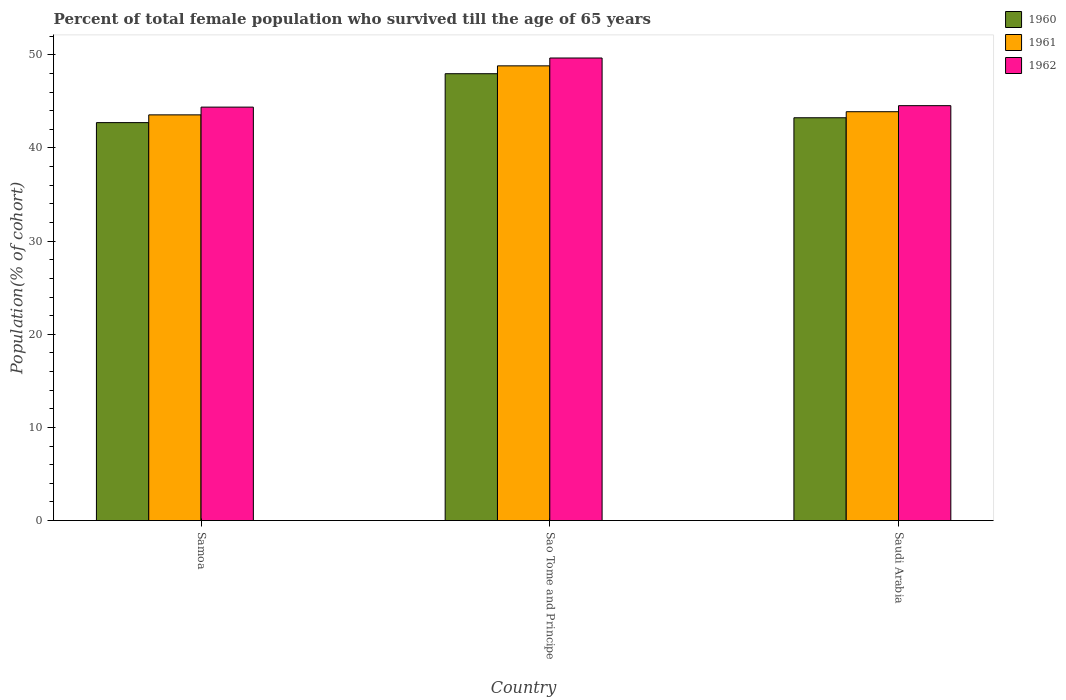How many groups of bars are there?
Your answer should be very brief. 3. How many bars are there on the 2nd tick from the left?
Give a very brief answer. 3. What is the label of the 3rd group of bars from the left?
Offer a very short reply. Saudi Arabia. What is the percentage of total female population who survived till the age of 65 years in 1960 in Samoa?
Your answer should be very brief. 42.72. Across all countries, what is the maximum percentage of total female population who survived till the age of 65 years in 1960?
Ensure brevity in your answer.  47.97. Across all countries, what is the minimum percentage of total female population who survived till the age of 65 years in 1960?
Keep it short and to the point. 42.72. In which country was the percentage of total female population who survived till the age of 65 years in 1960 maximum?
Ensure brevity in your answer.  Sao Tome and Principe. In which country was the percentage of total female population who survived till the age of 65 years in 1962 minimum?
Provide a short and direct response. Samoa. What is the total percentage of total female population who survived till the age of 65 years in 1962 in the graph?
Ensure brevity in your answer.  138.58. What is the difference between the percentage of total female population who survived till the age of 65 years in 1962 in Sao Tome and Principe and that in Saudi Arabia?
Make the answer very short. 5.12. What is the difference between the percentage of total female population who survived till the age of 65 years in 1960 in Samoa and the percentage of total female population who survived till the age of 65 years in 1962 in Saudi Arabia?
Offer a very short reply. -1.82. What is the average percentage of total female population who survived till the age of 65 years in 1961 per country?
Provide a short and direct response. 45.42. What is the difference between the percentage of total female population who survived till the age of 65 years of/in 1962 and percentage of total female population who survived till the age of 65 years of/in 1960 in Saudi Arabia?
Your answer should be compact. 1.3. In how many countries, is the percentage of total female population who survived till the age of 65 years in 1961 greater than 32 %?
Keep it short and to the point. 3. What is the ratio of the percentage of total female population who survived till the age of 65 years in 1961 in Samoa to that in Saudi Arabia?
Provide a short and direct response. 0.99. Is the difference between the percentage of total female population who survived till the age of 65 years in 1962 in Samoa and Sao Tome and Principe greater than the difference between the percentage of total female population who survived till the age of 65 years in 1960 in Samoa and Sao Tome and Principe?
Your response must be concise. No. What is the difference between the highest and the second highest percentage of total female population who survived till the age of 65 years in 1961?
Your answer should be compact. 5.26. What is the difference between the highest and the lowest percentage of total female population who survived till the age of 65 years in 1960?
Your answer should be compact. 5.25. What does the 1st bar from the left in Sao Tome and Principe represents?
Your answer should be compact. 1960. What does the 3rd bar from the right in Sao Tome and Principe represents?
Provide a succinct answer. 1960. How many countries are there in the graph?
Your response must be concise. 3. What is the difference between two consecutive major ticks on the Y-axis?
Your response must be concise. 10. Does the graph contain grids?
Offer a terse response. No. Where does the legend appear in the graph?
Your answer should be compact. Top right. How many legend labels are there?
Your response must be concise. 3. What is the title of the graph?
Your answer should be very brief. Percent of total female population who survived till the age of 65 years. Does "1991" appear as one of the legend labels in the graph?
Make the answer very short. No. What is the label or title of the X-axis?
Your answer should be very brief. Country. What is the label or title of the Y-axis?
Provide a short and direct response. Population(% of cohort). What is the Population(% of cohort) of 1960 in Samoa?
Your answer should be compact. 42.72. What is the Population(% of cohort) of 1961 in Samoa?
Provide a short and direct response. 43.55. What is the Population(% of cohort) of 1962 in Samoa?
Your answer should be compact. 44.39. What is the Population(% of cohort) in 1960 in Sao Tome and Principe?
Your answer should be very brief. 47.97. What is the Population(% of cohort) of 1961 in Sao Tome and Principe?
Your answer should be very brief. 48.81. What is the Population(% of cohort) of 1962 in Sao Tome and Principe?
Your answer should be very brief. 49.66. What is the Population(% of cohort) in 1960 in Saudi Arabia?
Keep it short and to the point. 43.24. What is the Population(% of cohort) in 1961 in Saudi Arabia?
Your response must be concise. 43.89. What is the Population(% of cohort) of 1962 in Saudi Arabia?
Your answer should be very brief. 44.54. Across all countries, what is the maximum Population(% of cohort) in 1960?
Offer a very short reply. 47.97. Across all countries, what is the maximum Population(% of cohort) of 1961?
Make the answer very short. 48.81. Across all countries, what is the maximum Population(% of cohort) in 1962?
Give a very brief answer. 49.66. Across all countries, what is the minimum Population(% of cohort) of 1960?
Your response must be concise. 42.72. Across all countries, what is the minimum Population(% of cohort) in 1961?
Your answer should be compact. 43.55. Across all countries, what is the minimum Population(% of cohort) in 1962?
Provide a short and direct response. 44.39. What is the total Population(% of cohort) in 1960 in the graph?
Offer a terse response. 133.93. What is the total Population(% of cohort) of 1961 in the graph?
Offer a terse response. 136.26. What is the total Population(% of cohort) of 1962 in the graph?
Your answer should be very brief. 138.58. What is the difference between the Population(% of cohort) of 1960 in Samoa and that in Sao Tome and Principe?
Provide a succinct answer. -5.25. What is the difference between the Population(% of cohort) in 1961 in Samoa and that in Sao Tome and Principe?
Ensure brevity in your answer.  -5.26. What is the difference between the Population(% of cohort) of 1962 in Samoa and that in Sao Tome and Principe?
Provide a short and direct response. -5.27. What is the difference between the Population(% of cohort) of 1960 in Samoa and that in Saudi Arabia?
Make the answer very short. -0.52. What is the difference between the Population(% of cohort) in 1961 in Samoa and that in Saudi Arabia?
Offer a terse response. -0.34. What is the difference between the Population(% of cohort) of 1962 in Samoa and that in Saudi Arabia?
Provide a succinct answer. -0.16. What is the difference between the Population(% of cohort) of 1960 in Sao Tome and Principe and that in Saudi Arabia?
Your answer should be very brief. 4.73. What is the difference between the Population(% of cohort) of 1961 in Sao Tome and Principe and that in Saudi Arabia?
Keep it short and to the point. 4.92. What is the difference between the Population(% of cohort) in 1962 in Sao Tome and Principe and that in Saudi Arabia?
Give a very brief answer. 5.12. What is the difference between the Population(% of cohort) of 1960 in Samoa and the Population(% of cohort) of 1961 in Sao Tome and Principe?
Keep it short and to the point. -6.09. What is the difference between the Population(% of cohort) of 1960 in Samoa and the Population(% of cohort) of 1962 in Sao Tome and Principe?
Your answer should be very brief. -6.94. What is the difference between the Population(% of cohort) of 1961 in Samoa and the Population(% of cohort) of 1962 in Sao Tome and Principe?
Your answer should be compact. -6.1. What is the difference between the Population(% of cohort) in 1960 in Samoa and the Population(% of cohort) in 1961 in Saudi Arabia?
Your response must be concise. -1.17. What is the difference between the Population(% of cohort) in 1960 in Samoa and the Population(% of cohort) in 1962 in Saudi Arabia?
Your response must be concise. -1.82. What is the difference between the Population(% of cohort) of 1961 in Samoa and the Population(% of cohort) of 1962 in Saudi Arabia?
Offer a very short reply. -0.99. What is the difference between the Population(% of cohort) in 1960 in Sao Tome and Principe and the Population(% of cohort) in 1961 in Saudi Arabia?
Ensure brevity in your answer.  4.08. What is the difference between the Population(% of cohort) in 1960 in Sao Tome and Principe and the Population(% of cohort) in 1962 in Saudi Arabia?
Provide a succinct answer. 3.43. What is the difference between the Population(% of cohort) of 1961 in Sao Tome and Principe and the Population(% of cohort) of 1962 in Saudi Arabia?
Your response must be concise. 4.27. What is the average Population(% of cohort) of 1960 per country?
Make the answer very short. 44.64. What is the average Population(% of cohort) in 1961 per country?
Provide a succinct answer. 45.42. What is the average Population(% of cohort) in 1962 per country?
Give a very brief answer. 46.19. What is the difference between the Population(% of cohort) in 1960 and Population(% of cohort) in 1961 in Samoa?
Provide a succinct answer. -0.83. What is the difference between the Population(% of cohort) of 1960 and Population(% of cohort) of 1962 in Samoa?
Give a very brief answer. -1.66. What is the difference between the Population(% of cohort) of 1961 and Population(% of cohort) of 1962 in Samoa?
Your answer should be very brief. -0.83. What is the difference between the Population(% of cohort) in 1960 and Population(% of cohort) in 1961 in Sao Tome and Principe?
Offer a very short reply. -0.84. What is the difference between the Population(% of cohort) of 1960 and Population(% of cohort) of 1962 in Sao Tome and Principe?
Provide a succinct answer. -1.69. What is the difference between the Population(% of cohort) in 1961 and Population(% of cohort) in 1962 in Sao Tome and Principe?
Provide a succinct answer. -0.84. What is the difference between the Population(% of cohort) in 1960 and Population(% of cohort) in 1961 in Saudi Arabia?
Give a very brief answer. -0.65. What is the difference between the Population(% of cohort) of 1960 and Population(% of cohort) of 1962 in Saudi Arabia?
Ensure brevity in your answer.  -1.3. What is the difference between the Population(% of cohort) of 1961 and Population(% of cohort) of 1962 in Saudi Arabia?
Your answer should be compact. -0.65. What is the ratio of the Population(% of cohort) in 1960 in Samoa to that in Sao Tome and Principe?
Your response must be concise. 0.89. What is the ratio of the Population(% of cohort) in 1961 in Samoa to that in Sao Tome and Principe?
Keep it short and to the point. 0.89. What is the ratio of the Population(% of cohort) in 1962 in Samoa to that in Sao Tome and Principe?
Give a very brief answer. 0.89. What is the ratio of the Population(% of cohort) in 1960 in Samoa to that in Saudi Arabia?
Your answer should be compact. 0.99. What is the ratio of the Population(% of cohort) in 1962 in Samoa to that in Saudi Arabia?
Offer a terse response. 1. What is the ratio of the Population(% of cohort) of 1960 in Sao Tome and Principe to that in Saudi Arabia?
Offer a very short reply. 1.11. What is the ratio of the Population(% of cohort) in 1961 in Sao Tome and Principe to that in Saudi Arabia?
Offer a terse response. 1.11. What is the ratio of the Population(% of cohort) of 1962 in Sao Tome and Principe to that in Saudi Arabia?
Your answer should be compact. 1.11. What is the difference between the highest and the second highest Population(% of cohort) of 1960?
Offer a very short reply. 4.73. What is the difference between the highest and the second highest Population(% of cohort) of 1961?
Make the answer very short. 4.92. What is the difference between the highest and the second highest Population(% of cohort) of 1962?
Provide a succinct answer. 5.12. What is the difference between the highest and the lowest Population(% of cohort) of 1960?
Ensure brevity in your answer.  5.25. What is the difference between the highest and the lowest Population(% of cohort) in 1961?
Give a very brief answer. 5.26. What is the difference between the highest and the lowest Population(% of cohort) in 1962?
Offer a very short reply. 5.27. 